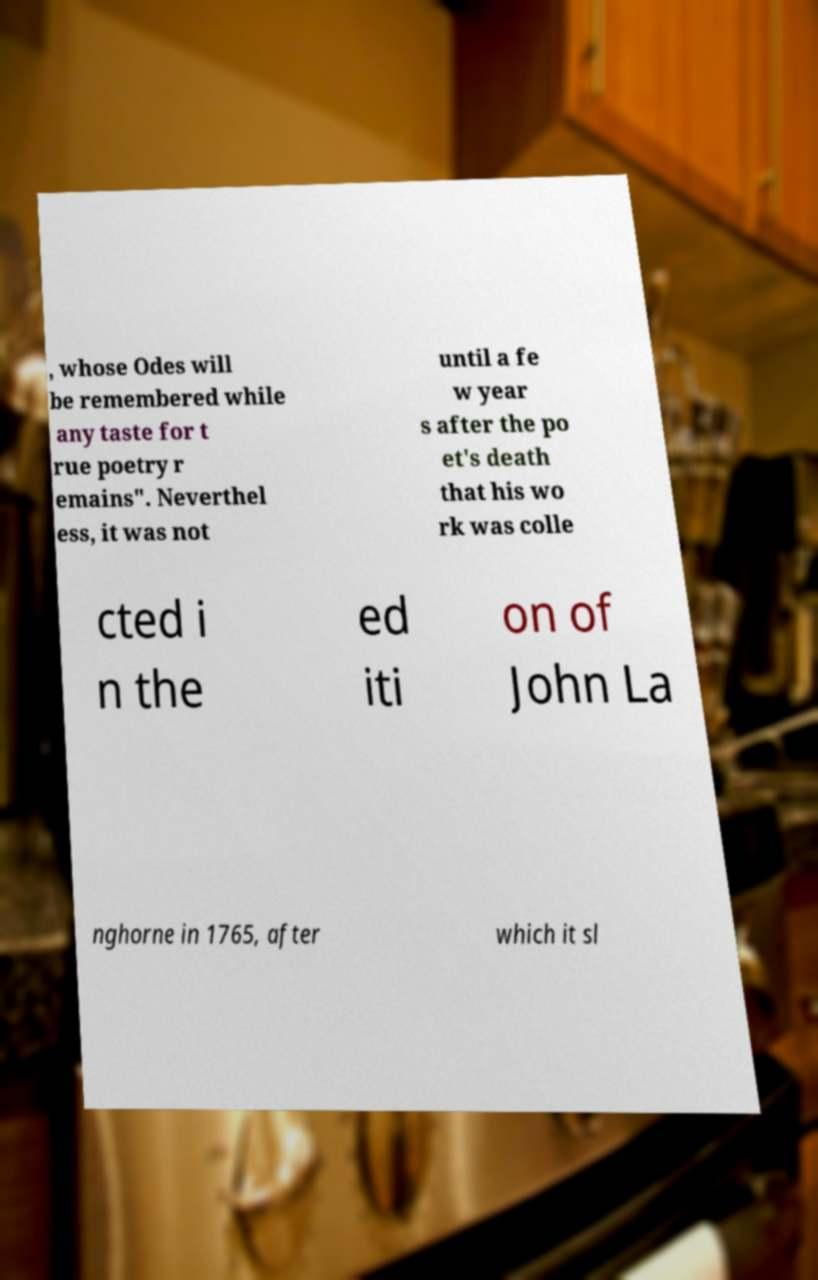Please read and relay the text visible in this image. What does it say? , whose Odes will be remembered while any taste for t rue poetry r emains". Neverthel ess, it was not until a fe w year s after the po et's death that his wo rk was colle cted i n the ed iti on of John La nghorne in 1765, after which it sl 